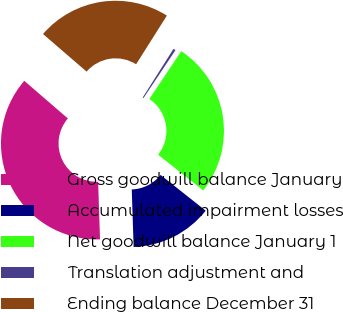Convert chart. <chart><loc_0><loc_0><loc_500><loc_500><pie_chart><fcel>Gross goodwill balance January<fcel>Accumulated impairment losses<fcel>Net goodwill balance January 1<fcel>Translation adjustment and<fcel>Ending balance December 31<nl><fcel>36.85%<fcel>13.82%<fcel>26.29%<fcel>0.39%<fcel>22.64%<nl></chart> 